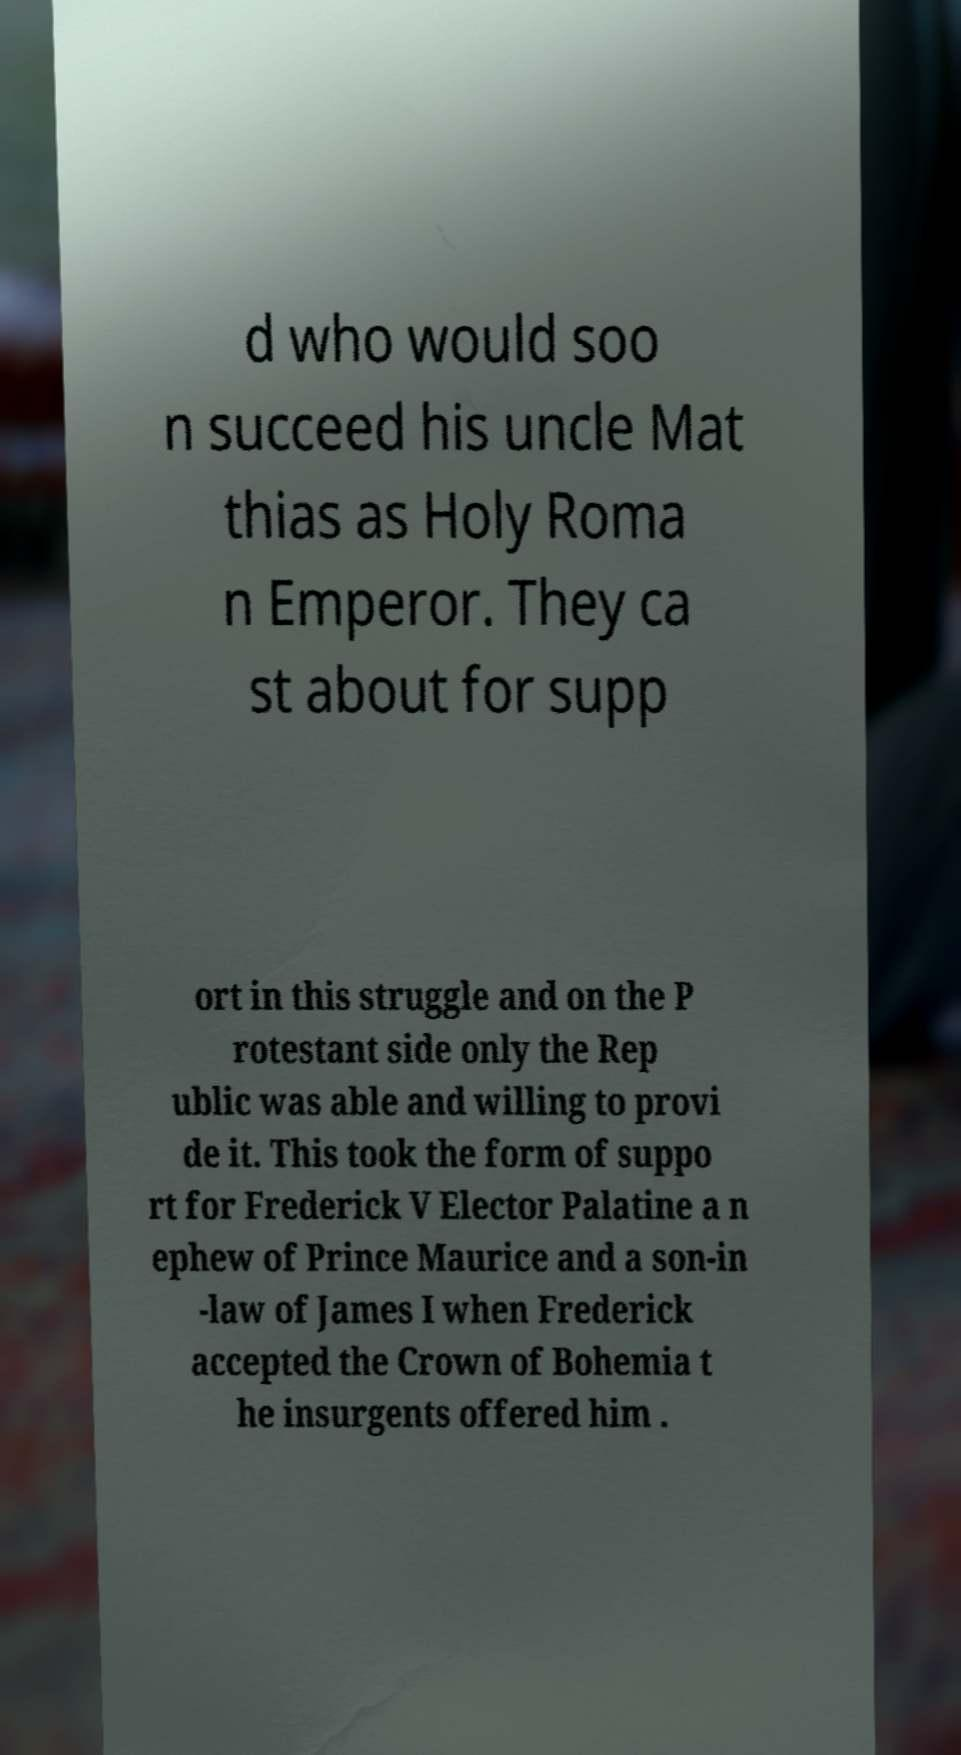Please identify and transcribe the text found in this image. d who would soo n succeed his uncle Mat thias as Holy Roma n Emperor. They ca st about for supp ort in this struggle and on the P rotestant side only the Rep ublic was able and willing to provi de it. This took the form of suppo rt for Frederick V Elector Palatine a n ephew of Prince Maurice and a son-in -law of James I when Frederick accepted the Crown of Bohemia t he insurgents offered him . 